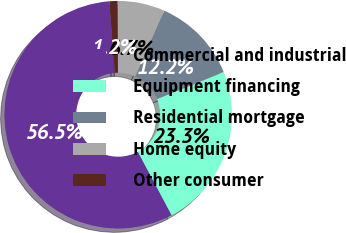Convert chart. <chart><loc_0><loc_0><loc_500><loc_500><pie_chart><fcel>Commercial and industrial<fcel>Equipment financing<fcel>Residential mortgage<fcel>Home equity<fcel>Other consumer<nl><fcel>56.52%<fcel>23.34%<fcel>12.25%<fcel>6.71%<fcel>1.18%<nl></chart> 